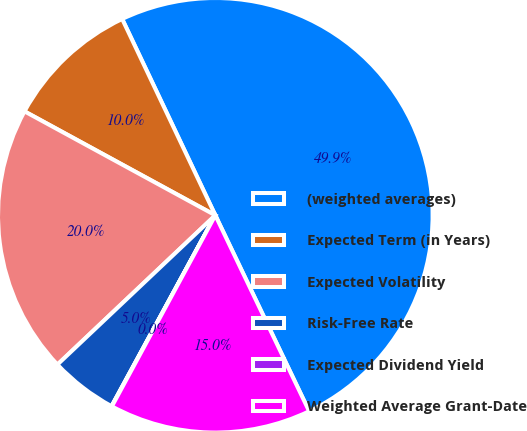Convert chart to OTSL. <chart><loc_0><loc_0><loc_500><loc_500><pie_chart><fcel>(weighted averages)<fcel>Expected Term (in Years)<fcel>Expected Volatility<fcel>Risk-Free Rate<fcel>Expected Dividend Yield<fcel>Weighted Average Grant-Date<nl><fcel>49.94%<fcel>10.01%<fcel>19.99%<fcel>5.02%<fcel>0.03%<fcel>15.0%<nl></chart> 